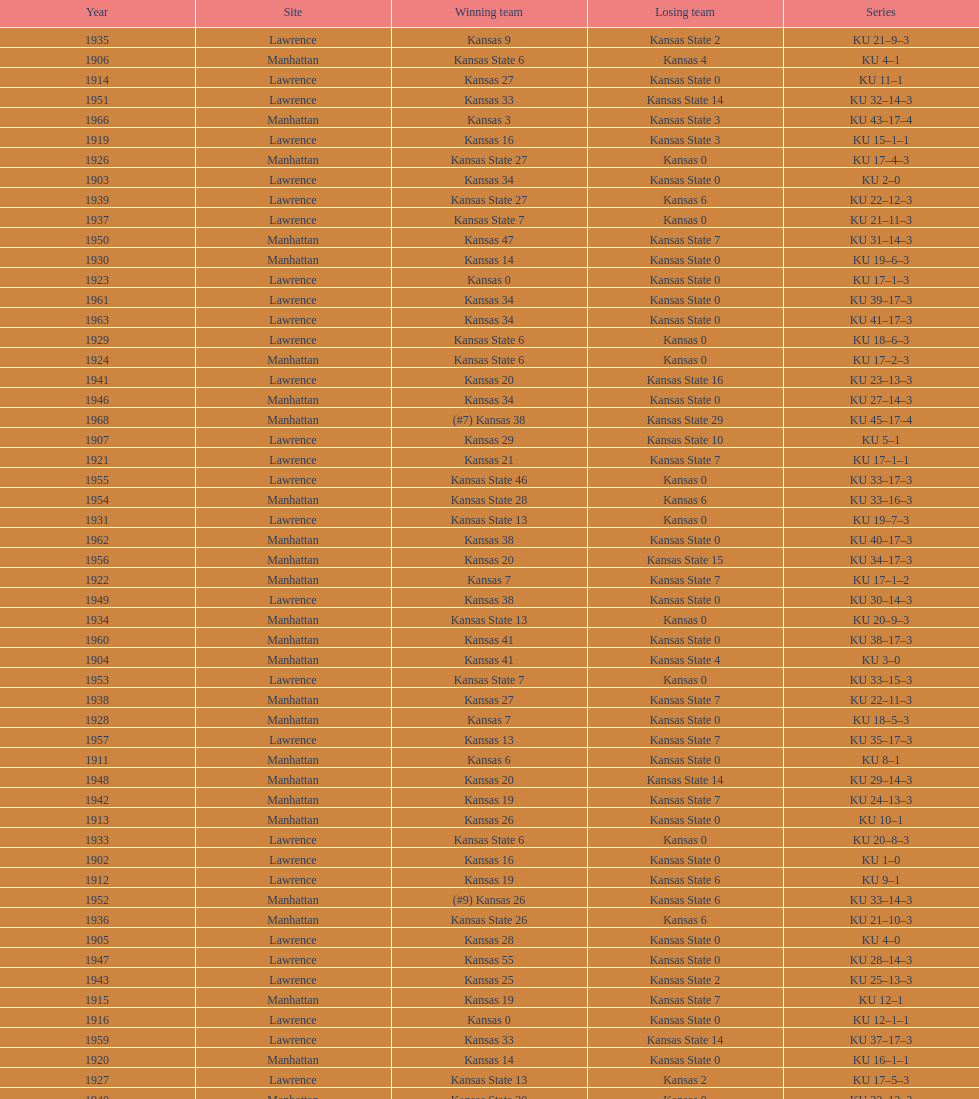Who had the most wins in the 1950's: kansas or kansas state? Kansas. 